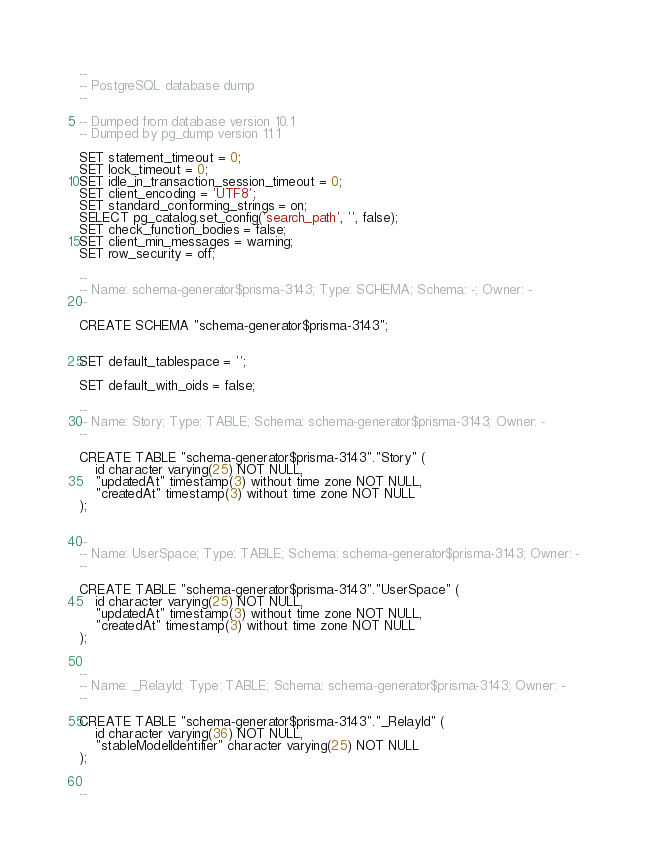<code> <loc_0><loc_0><loc_500><loc_500><_SQL_>--
-- PostgreSQL database dump
--

-- Dumped from database version 10.1
-- Dumped by pg_dump version 11.1

SET statement_timeout = 0;
SET lock_timeout = 0;
SET idle_in_transaction_session_timeout = 0;
SET client_encoding = 'UTF8';
SET standard_conforming_strings = on;
SELECT pg_catalog.set_config('search_path', '', false);
SET check_function_bodies = false;
SET client_min_messages = warning;
SET row_security = off;

--
-- Name: schema-generator$prisma-3143; Type: SCHEMA; Schema: -; Owner: -
--

CREATE SCHEMA "schema-generator$prisma-3143";


SET default_tablespace = '';

SET default_with_oids = false;

--
-- Name: Story; Type: TABLE; Schema: schema-generator$prisma-3143; Owner: -
--

CREATE TABLE "schema-generator$prisma-3143"."Story" (
    id character varying(25) NOT NULL,
    "updatedAt" timestamp(3) without time zone NOT NULL,
    "createdAt" timestamp(3) without time zone NOT NULL
);


--
-- Name: UserSpace; Type: TABLE; Schema: schema-generator$prisma-3143; Owner: -
--

CREATE TABLE "schema-generator$prisma-3143"."UserSpace" (
    id character varying(25) NOT NULL,
    "updatedAt" timestamp(3) without time zone NOT NULL,
    "createdAt" timestamp(3) without time zone NOT NULL
);


--
-- Name: _RelayId; Type: TABLE; Schema: schema-generator$prisma-3143; Owner: -
--

CREATE TABLE "schema-generator$prisma-3143"."_RelayId" (
    id character varying(36) NOT NULL,
    "stableModelIdentifier" character varying(25) NOT NULL
);


--</code> 